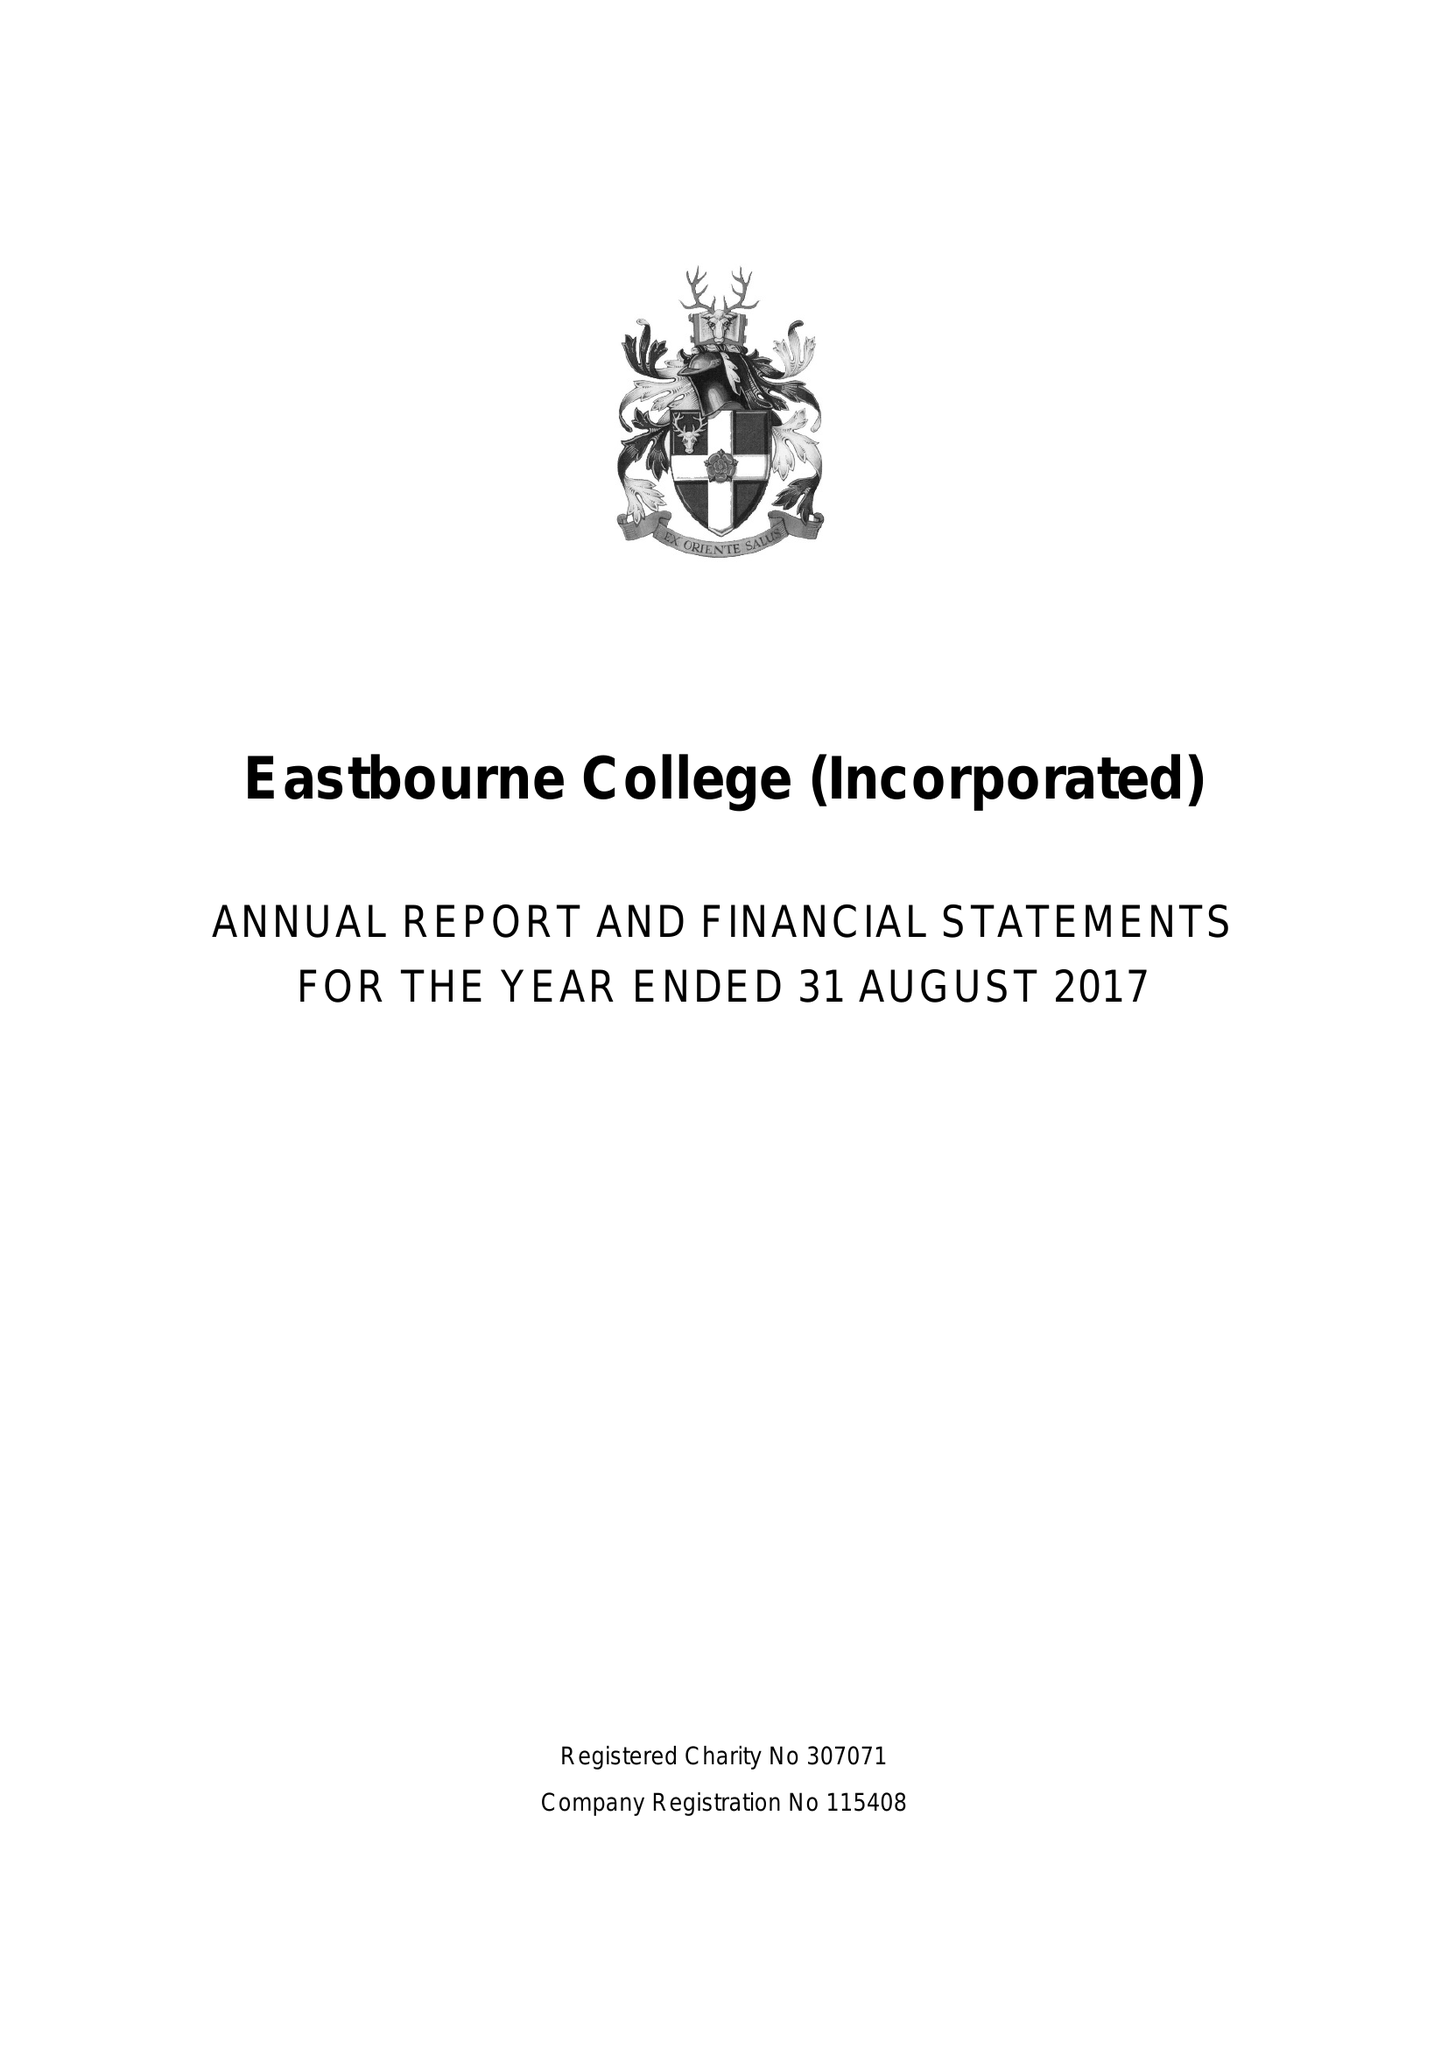What is the value for the charity_name?
Answer the question using a single word or phrase. Eastbourne College (Incorporated) 